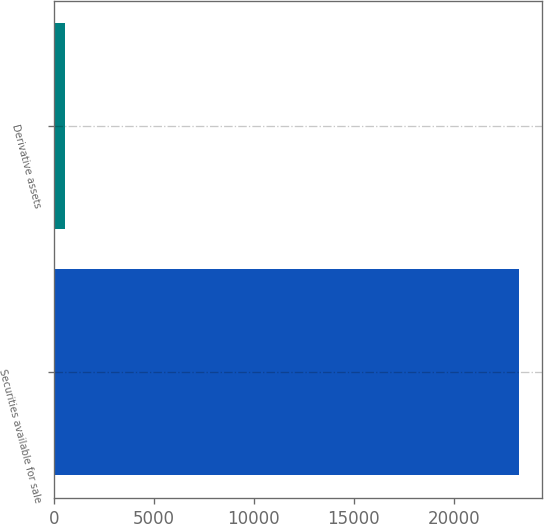Convert chart. <chart><loc_0><loc_0><loc_500><loc_500><bar_chart><fcel>Securities available for sale<fcel>Derivative assets<nl><fcel>23270<fcel>566<nl></chart> 